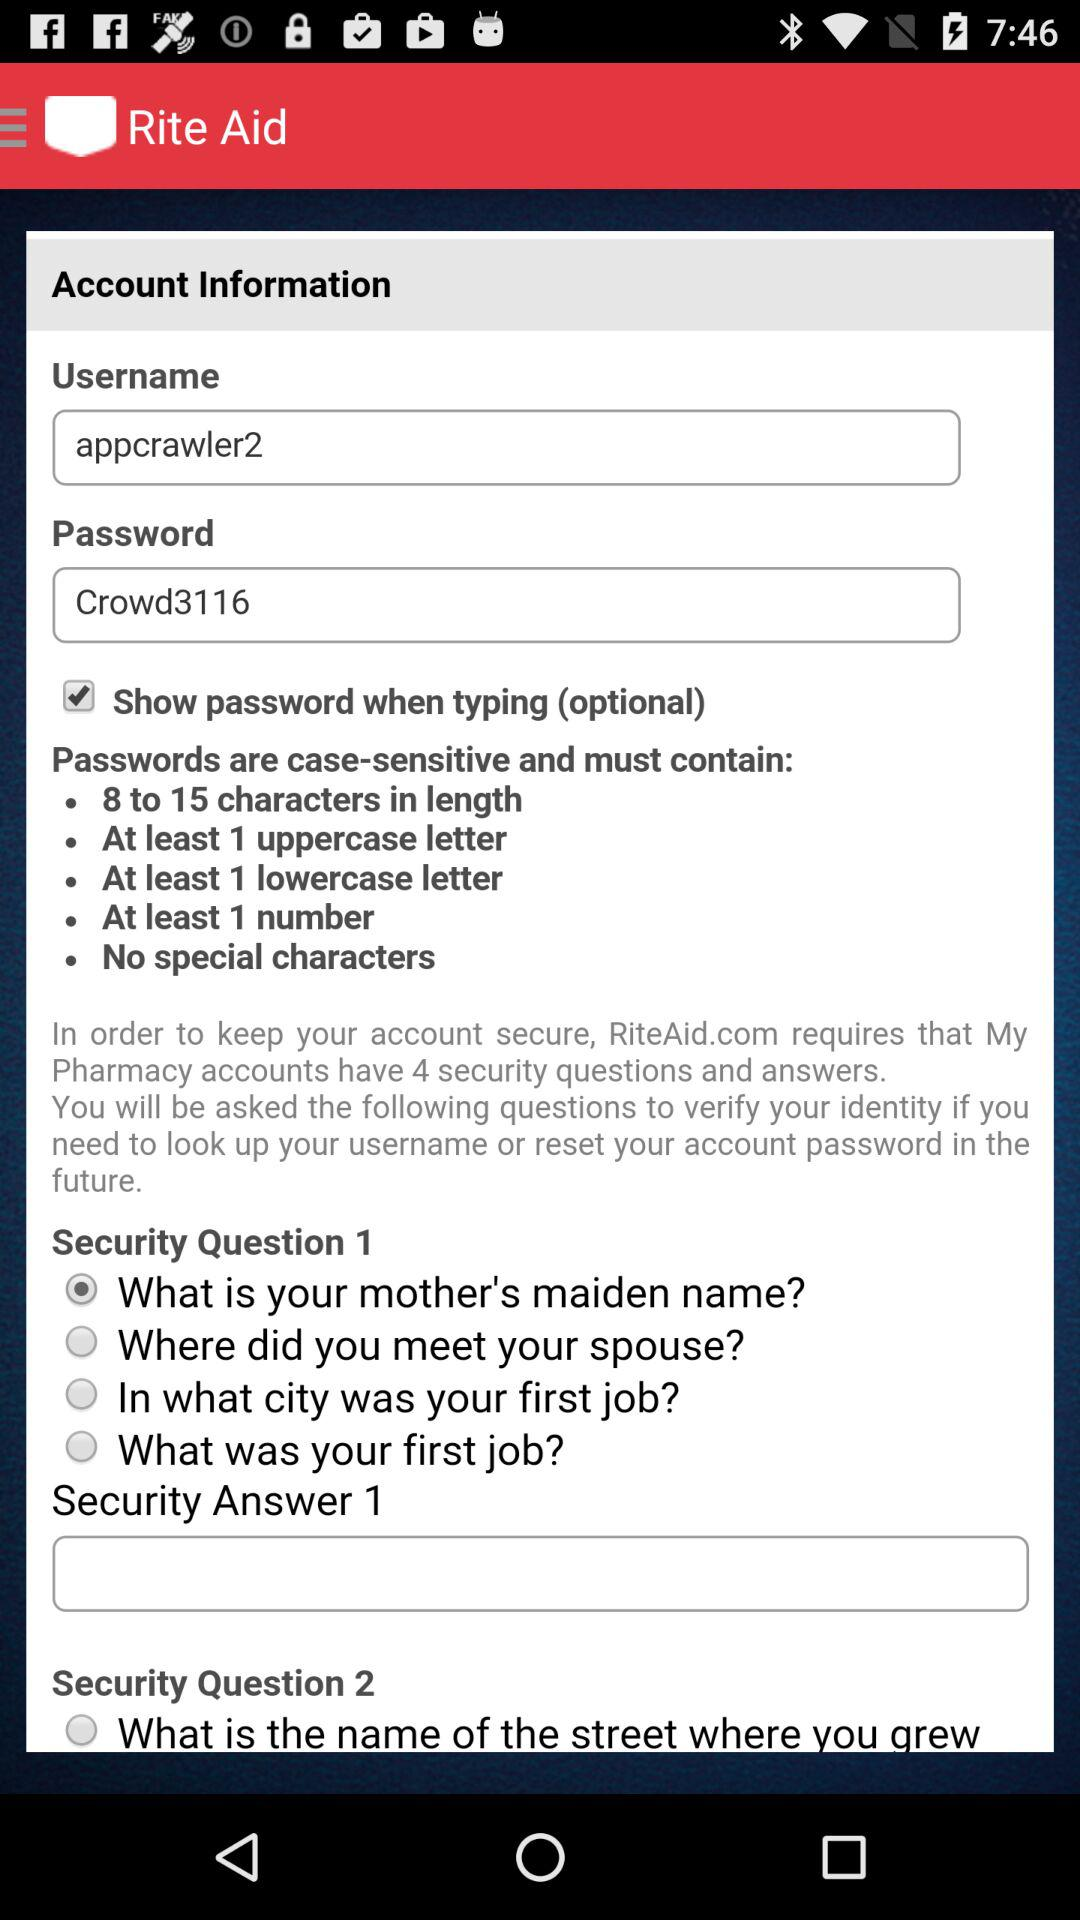How many security questions are there?
Answer the question using a single word or phrase. 4 